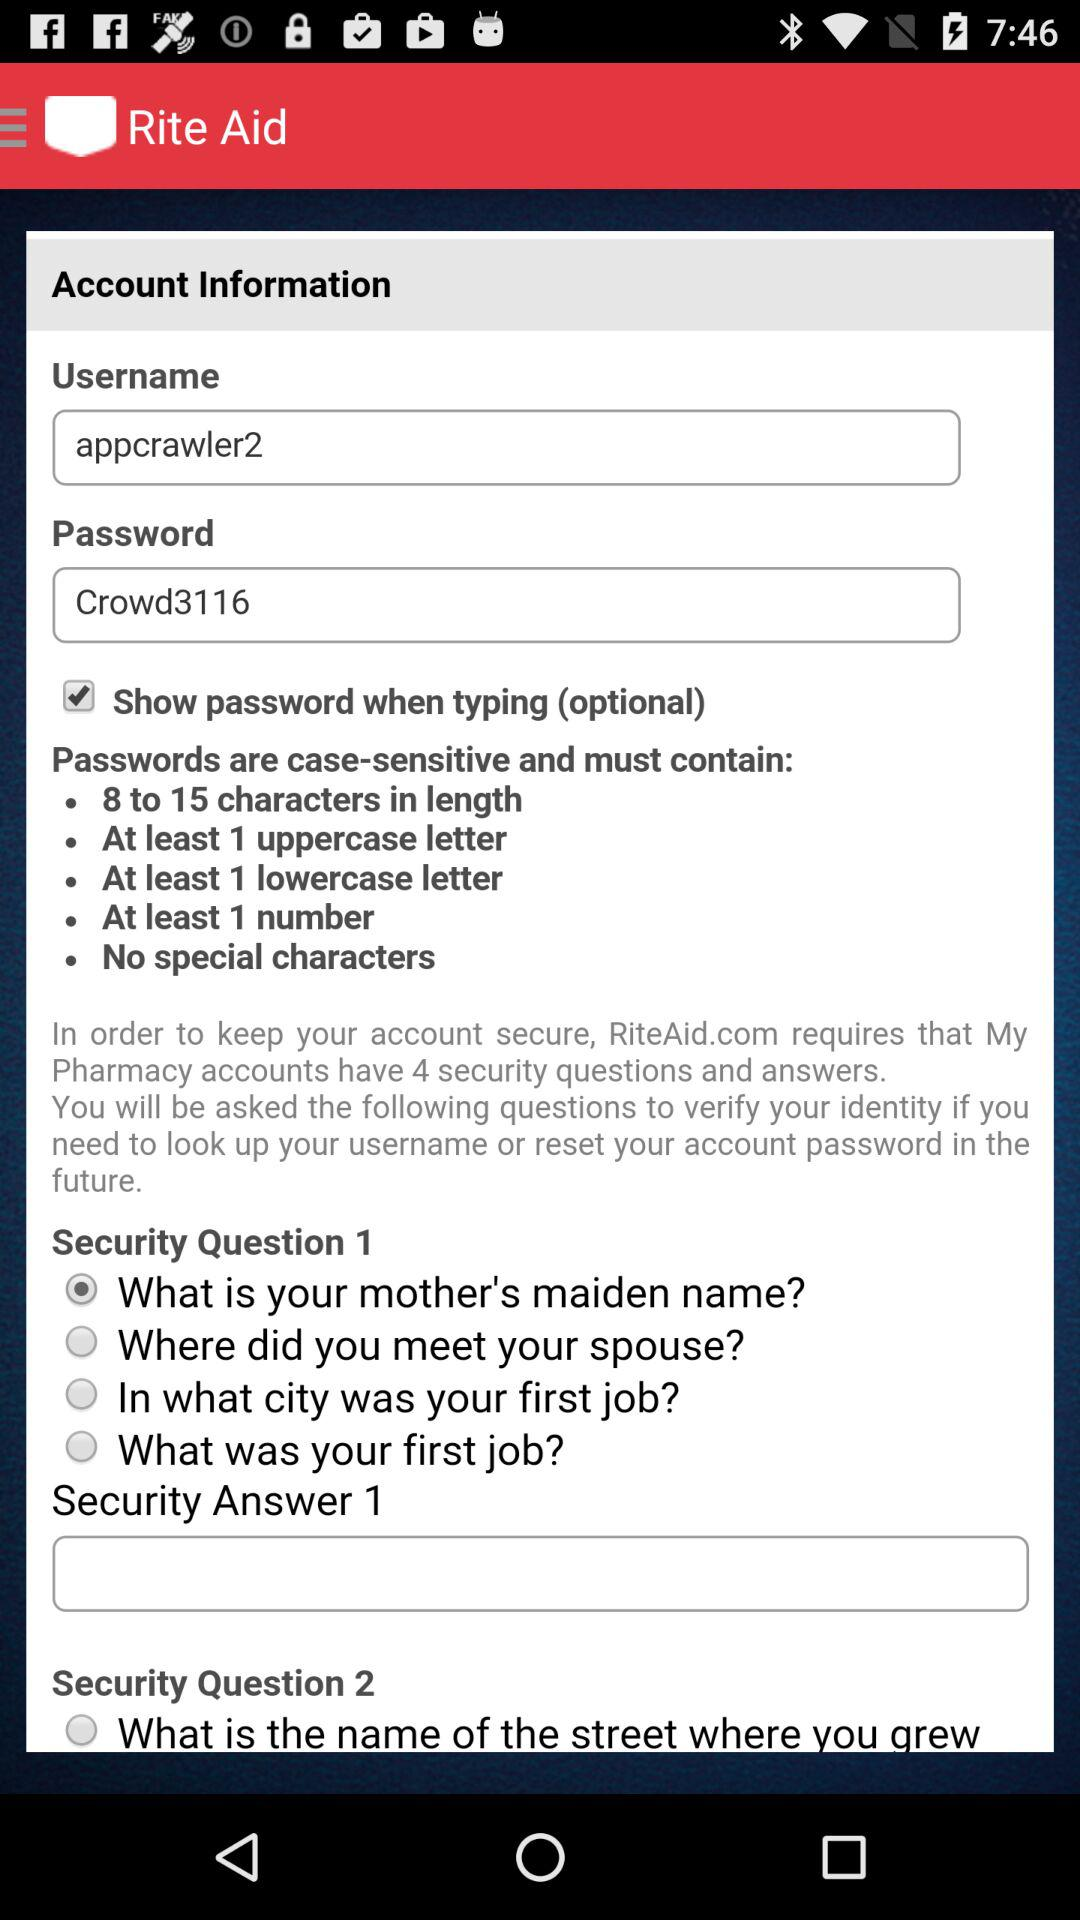How many security questions are there?
Answer the question using a single word or phrase. 4 